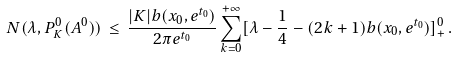<formula> <loc_0><loc_0><loc_500><loc_500>N ( \lambda , P ^ { 0 } _ { K } ( A ^ { 0 } ) ) \, \leq \, \frac { | K | b ( x _ { 0 } , e ^ { t _ { 0 } } ) } { 2 \pi e ^ { t _ { 0 } } } \sum _ { k = 0 } ^ { + \infty } [ \lambda - \frac { 1 } { 4 } - ( 2 k + 1 ) b ( x _ { 0 } , e ^ { t _ { 0 } } ) ] _ { + } ^ { 0 } \, .</formula> 